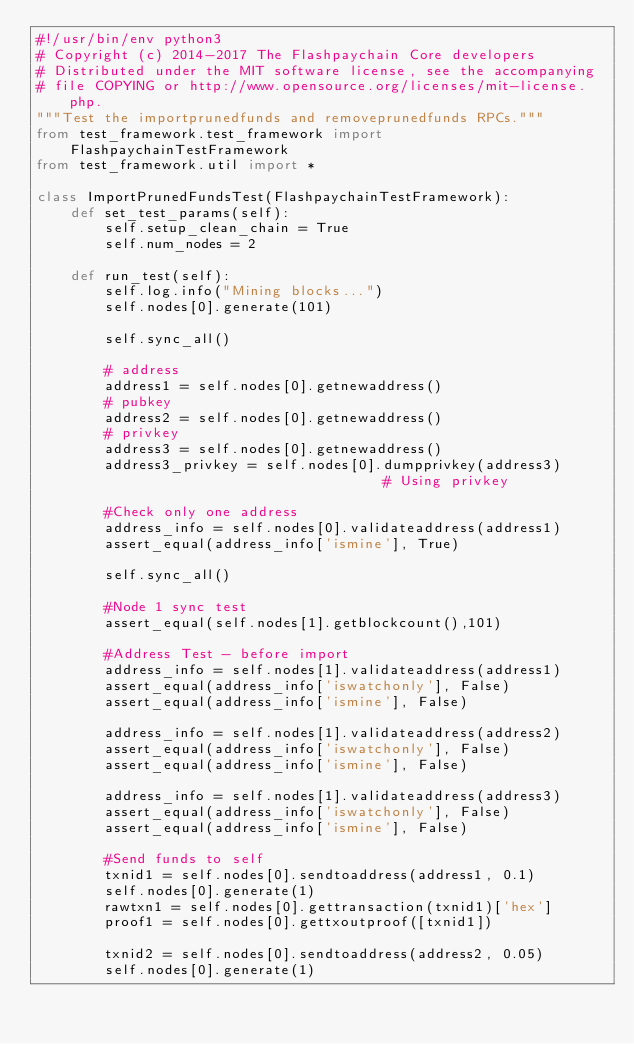Convert code to text. <code><loc_0><loc_0><loc_500><loc_500><_Python_>#!/usr/bin/env python3
# Copyright (c) 2014-2017 The Flashpaychain Core developers
# Distributed under the MIT software license, see the accompanying
# file COPYING or http://www.opensource.org/licenses/mit-license.php.
"""Test the importprunedfunds and removeprunedfunds RPCs."""
from test_framework.test_framework import FlashpaychainTestFramework
from test_framework.util import *

class ImportPrunedFundsTest(FlashpaychainTestFramework):
    def set_test_params(self):
        self.setup_clean_chain = True
        self.num_nodes = 2

    def run_test(self):
        self.log.info("Mining blocks...")
        self.nodes[0].generate(101)

        self.sync_all()
        
        # address
        address1 = self.nodes[0].getnewaddress()
        # pubkey
        address2 = self.nodes[0].getnewaddress()
        # privkey
        address3 = self.nodes[0].getnewaddress()
        address3_privkey = self.nodes[0].dumpprivkey(address3)                              # Using privkey

        #Check only one address
        address_info = self.nodes[0].validateaddress(address1)
        assert_equal(address_info['ismine'], True)

        self.sync_all()

        #Node 1 sync test
        assert_equal(self.nodes[1].getblockcount(),101)

        #Address Test - before import
        address_info = self.nodes[1].validateaddress(address1)
        assert_equal(address_info['iswatchonly'], False)
        assert_equal(address_info['ismine'], False)

        address_info = self.nodes[1].validateaddress(address2)
        assert_equal(address_info['iswatchonly'], False)
        assert_equal(address_info['ismine'], False)

        address_info = self.nodes[1].validateaddress(address3)
        assert_equal(address_info['iswatchonly'], False)
        assert_equal(address_info['ismine'], False)

        #Send funds to self
        txnid1 = self.nodes[0].sendtoaddress(address1, 0.1)
        self.nodes[0].generate(1)
        rawtxn1 = self.nodes[0].gettransaction(txnid1)['hex']
        proof1 = self.nodes[0].gettxoutproof([txnid1])

        txnid2 = self.nodes[0].sendtoaddress(address2, 0.05)
        self.nodes[0].generate(1)</code> 